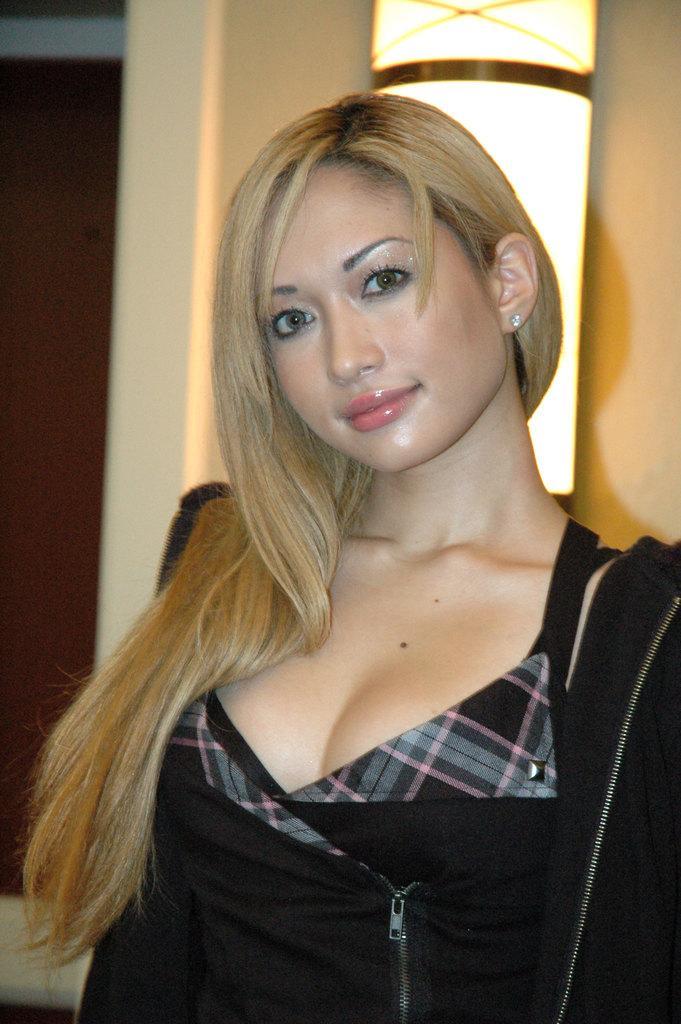Can you describe this image briefly? In this picture we can see a woman, she is smiling, behind her we can see a light. 